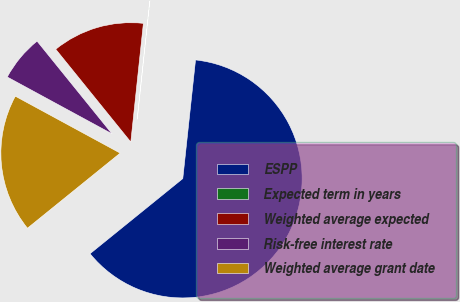Convert chart. <chart><loc_0><loc_0><loc_500><loc_500><pie_chart><fcel>ESPP<fcel>Expected term in years<fcel>Weighted average expected<fcel>Risk-free interest rate<fcel>Weighted average grant date<nl><fcel>62.47%<fcel>0.02%<fcel>12.51%<fcel>6.26%<fcel>18.75%<nl></chart> 